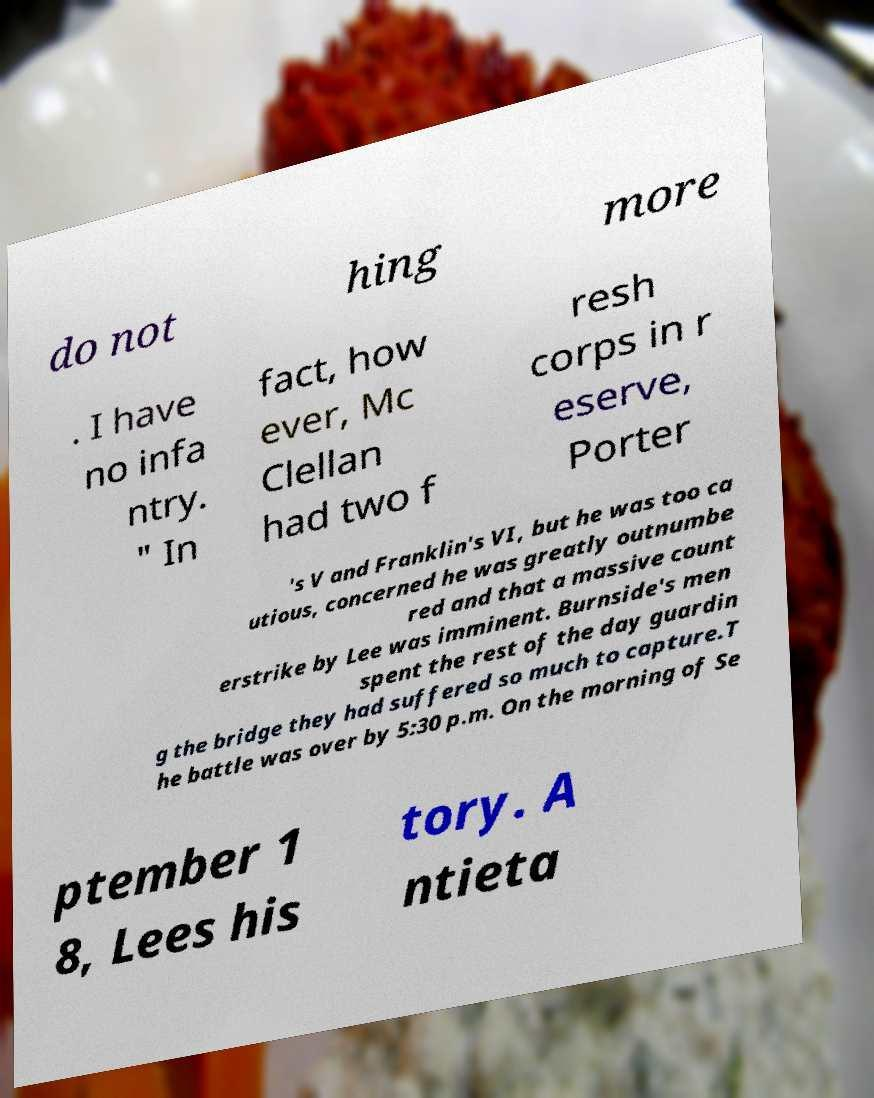Could you assist in decoding the text presented in this image and type it out clearly? do not hing more . I have no infa ntry. " In fact, how ever, Mc Clellan had two f resh corps in r eserve, Porter 's V and Franklin's VI, but he was too ca utious, concerned he was greatly outnumbe red and that a massive count erstrike by Lee was imminent. Burnside's men spent the rest of the day guardin g the bridge they had suffered so much to capture.T he battle was over by 5:30 p.m. On the morning of Se ptember 1 8, Lees his tory. A ntieta 